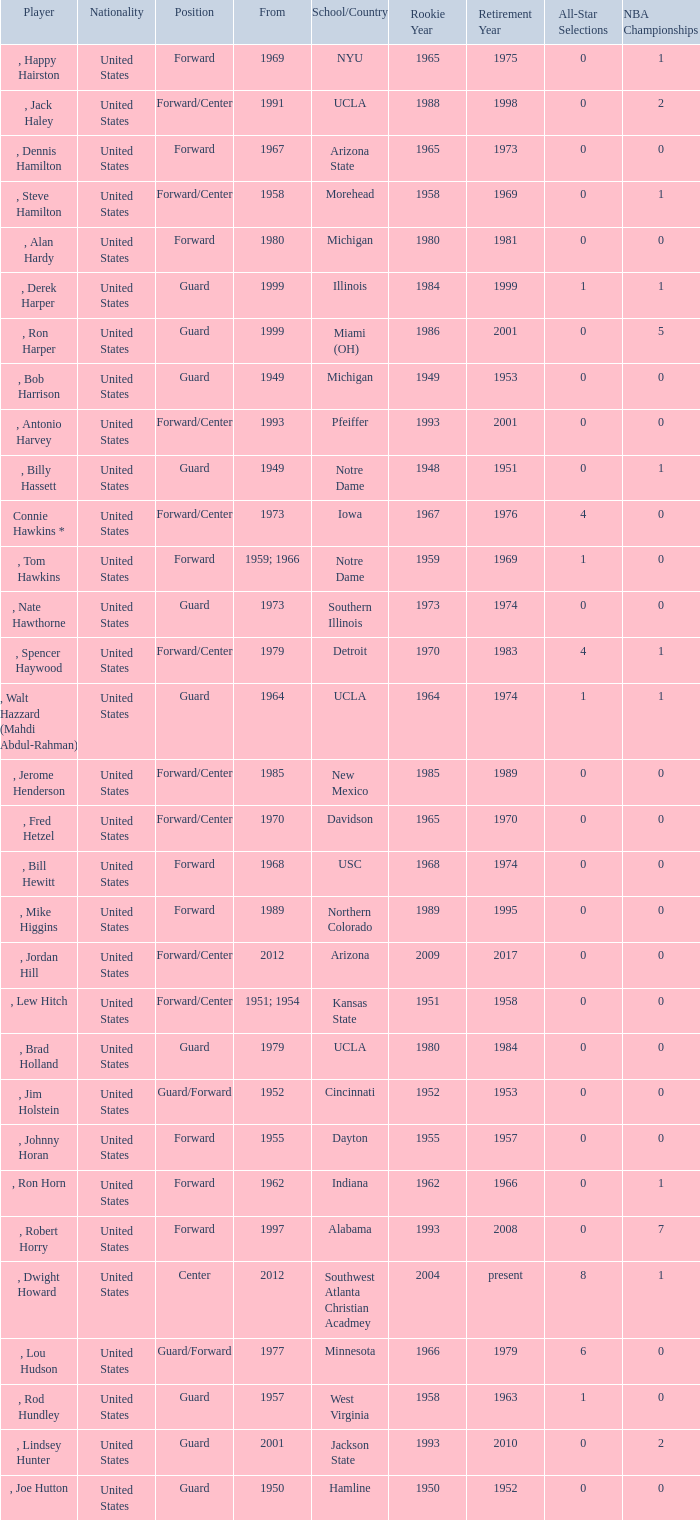Which school has the player that started in 1958? Morehead. 